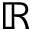Convert formula to latex. <formula><loc_0><loc_0><loc_500><loc_500>\mathbb { R }</formula> 